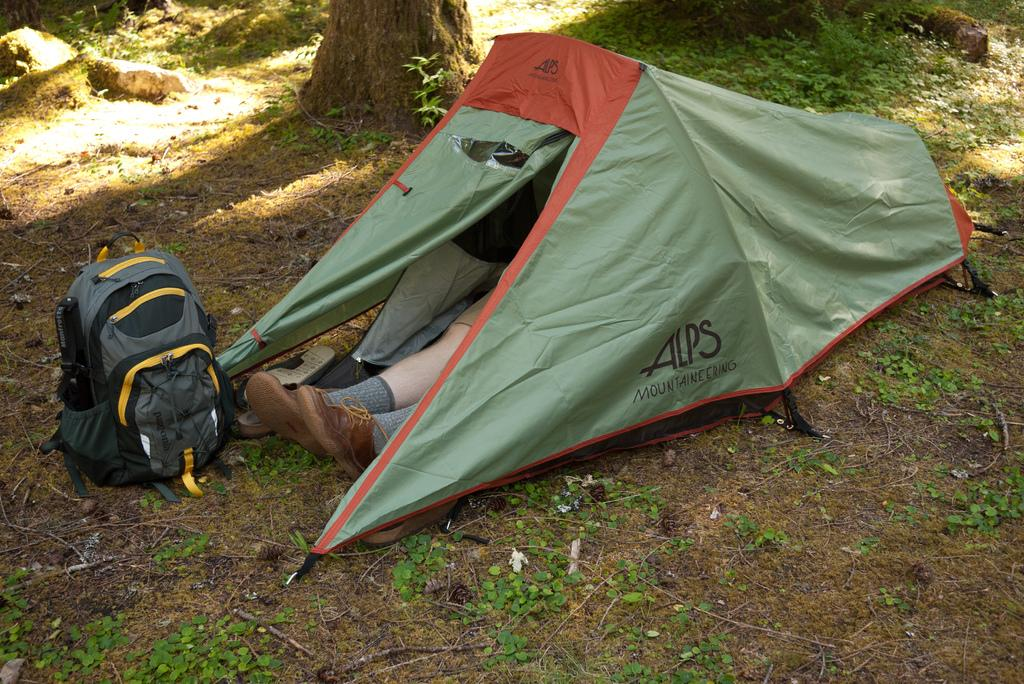What structure is visible in the image? There is a camping tent in the image. Who or what is inside the tent? There is a person inside the tent. What object is placed in front of the tent? There is a bag in front of the tent. What type of natural elements can be seen in the image? There are plants, trees, and rocks in the image. What type of hen can be seen walking around the camping tent in the image? There is no hen present in the image; it only features a camping tent, a person, a bag, plants, trees, and rocks. 